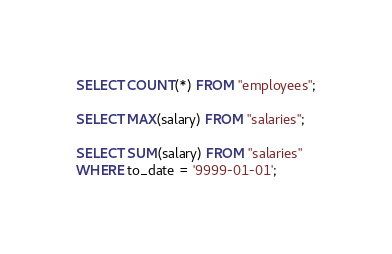Convert code to text. <code><loc_0><loc_0><loc_500><loc_500><_SQL_>SELECT COUNT(*) FROM "employees";

SELECT MAX(salary) FROM "salaries";

SELECT SUM(salary) FROM "salaries"
WHERE to_date = '9999-01-01';
</code> 